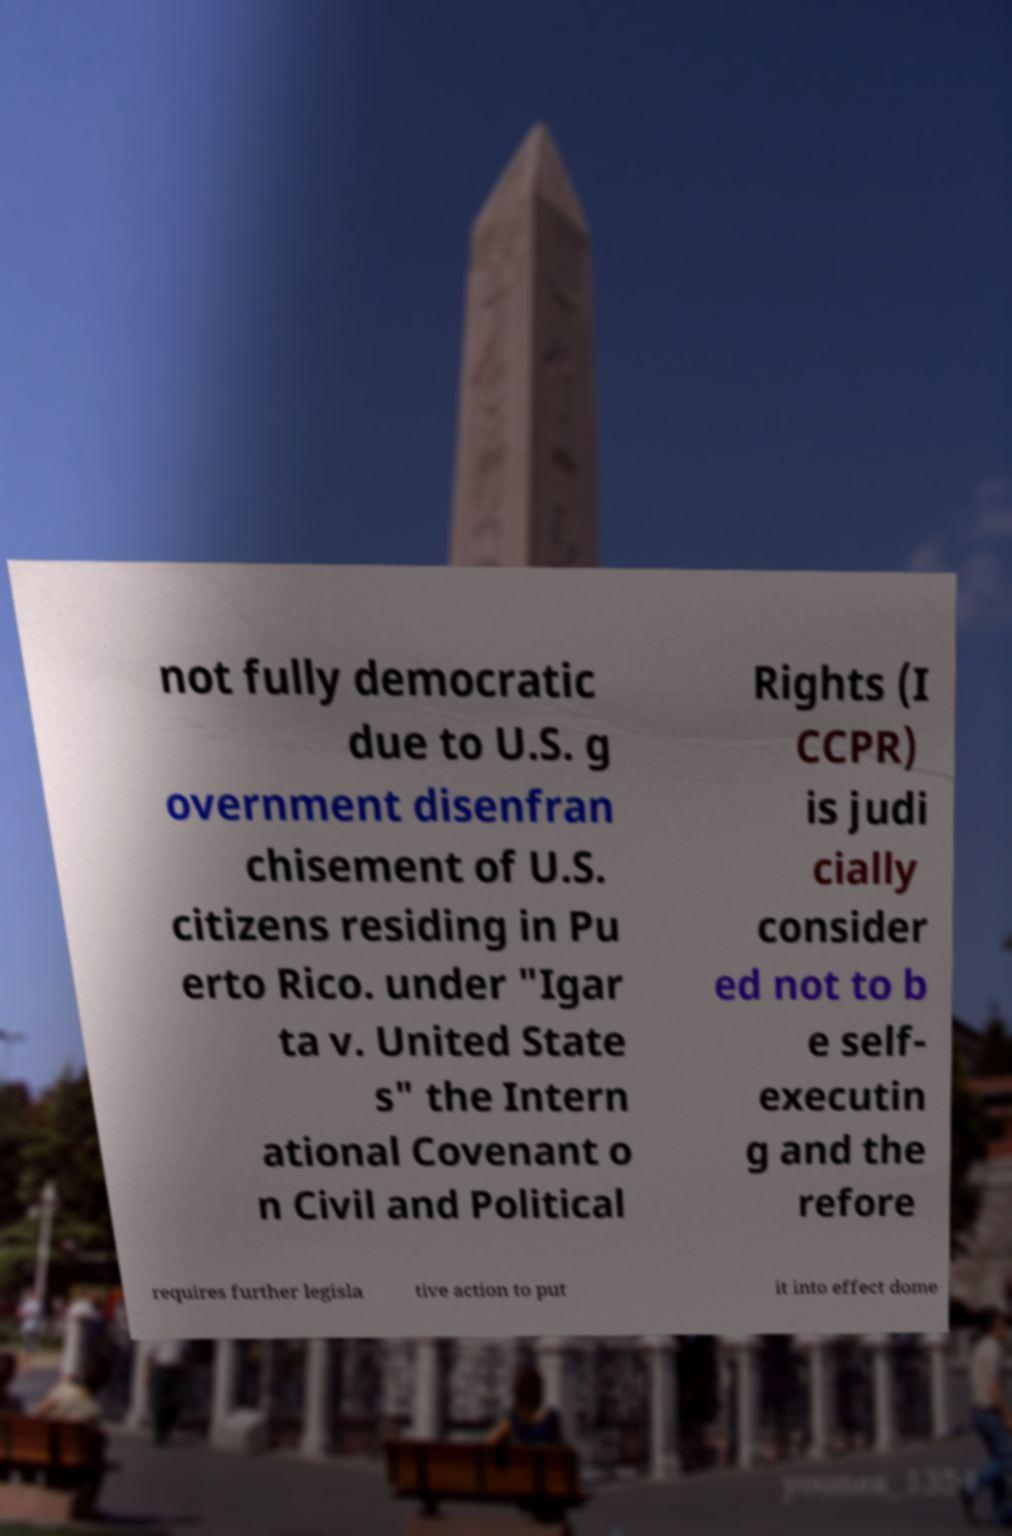Could you assist in decoding the text presented in this image and type it out clearly? not fully democratic due to U.S. g overnment disenfran chisement of U.S. citizens residing in Pu erto Rico. under "Igar ta v. United State s" the Intern ational Covenant o n Civil and Political Rights (I CCPR) is judi cially consider ed not to b e self- executin g and the refore requires further legisla tive action to put it into effect dome 